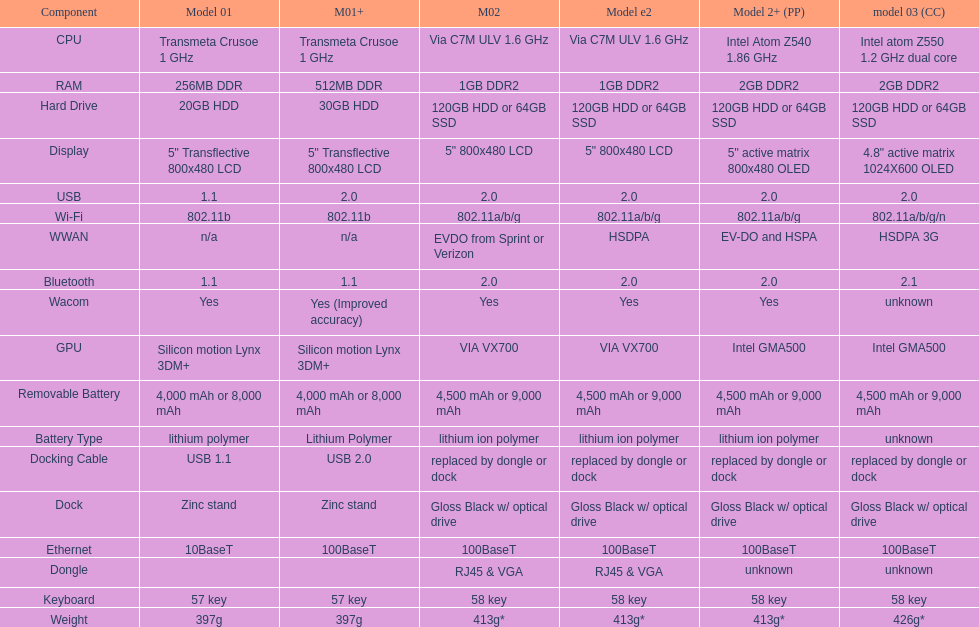What is the component before usb? Display. 